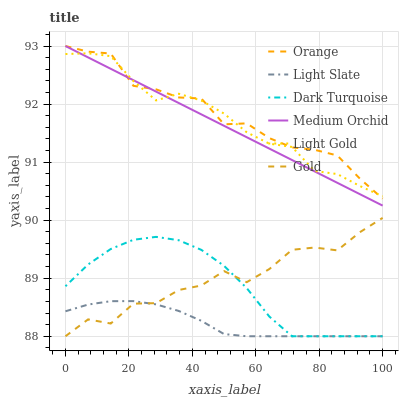Does Light Slate have the minimum area under the curve?
Answer yes or no. Yes. Does Orange have the maximum area under the curve?
Answer yes or no. Yes. Does Dark Turquoise have the minimum area under the curve?
Answer yes or no. No. Does Dark Turquoise have the maximum area under the curve?
Answer yes or no. No. Is Medium Orchid the smoothest?
Answer yes or no. Yes. Is Gold the roughest?
Answer yes or no. Yes. Is Light Slate the smoothest?
Answer yes or no. No. Is Light Slate the roughest?
Answer yes or no. No. Does Gold have the lowest value?
Answer yes or no. Yes. Does Medium Orchid have the lowest value?
Answer yes or no. No. Does Orange have the highest value?
Answer yes or no. Yes. Does Dark Turquoise have the highest value?
Answer yes or no. No. Is Dark Turquoise less than Orange?
Answer yes or no. Yes. Is Light Gold greater than Light Slate?
Answer yes or no. Yes. Does Orange intersect Medium Orchid?
Answer yes or no. Yes. Is Orange less than Medium Orchid?
Answer yes or no. No. Is Orange greater than Medium Orchid?
Answer yes or no. No. Does Dark Turquoise intersect Orange?
Answer yes or no. No. 